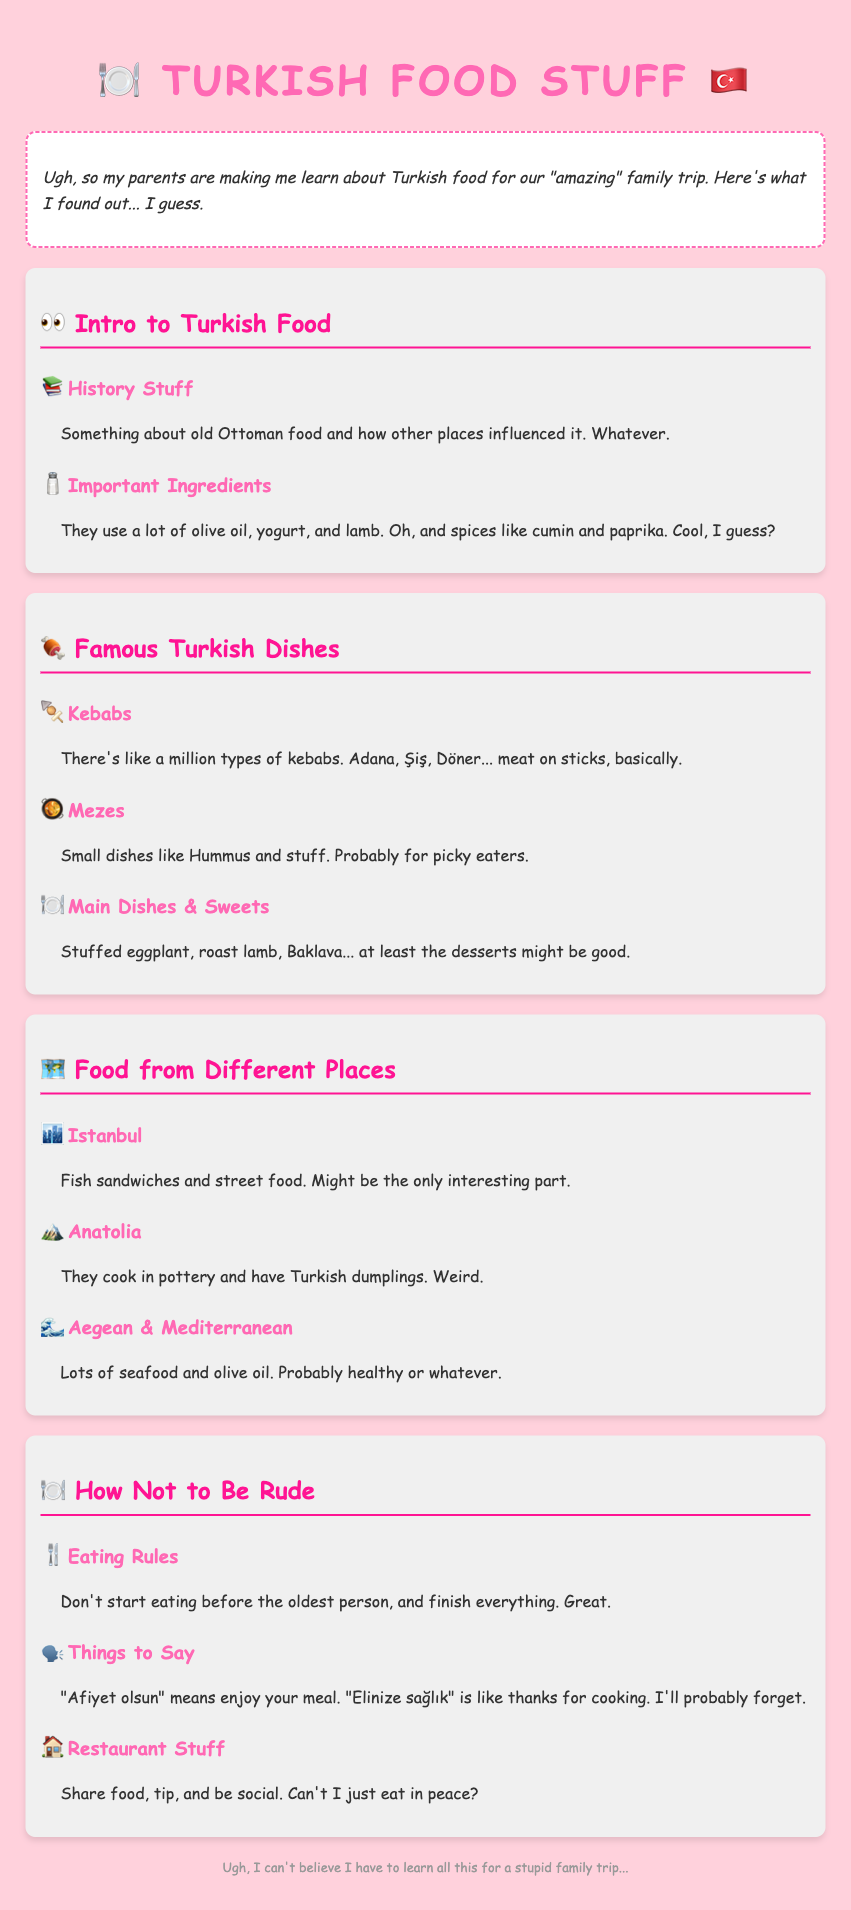what is the title of the document? The title of the document is provided in the head section of the HTML, which is "Boring Turkish Food Stuff."
Answer: Boring Turkish Food Stuff what ingredient is commonly used in Turkish cuisine? The document mentions that olive oil is an important ingredient in Turkish cuisine.
Answer: Olive oil how many famous Turkish dishes are listed? The syllabus lists three categories under famous Turkish dishes: Kebabs, Mezes, and Main Dishes & Sweets.
Answer: Three what is a traditional way of cooking in Anatolia? According to the document, they cook in pottery in Anatolia.
Answer: Pottery what should you say to mean enjoy your meal? The document states that "Afiyet olsun" means enjoy your meal.
Answer: Afiyet olsun what is the main dining etiquette rule mentioned? The most important dining etiquette rule mentioned is to not start eating before the oldest person.
Answer: Not start eating before the oldest person what is the topic of the third module? The third module is about food from different places.
Answer: Food from Different Places what is one example of a dish found in the main dishes & sweets category? The document gives an example of Baklava as a dish found in this category.
Answer: Baklava what type of food is common in the Aegean & Mediterranean regions? The syllabus states that lots of seafood is common in the Aegean & Mediterranean regions.
Answer: Seafood 